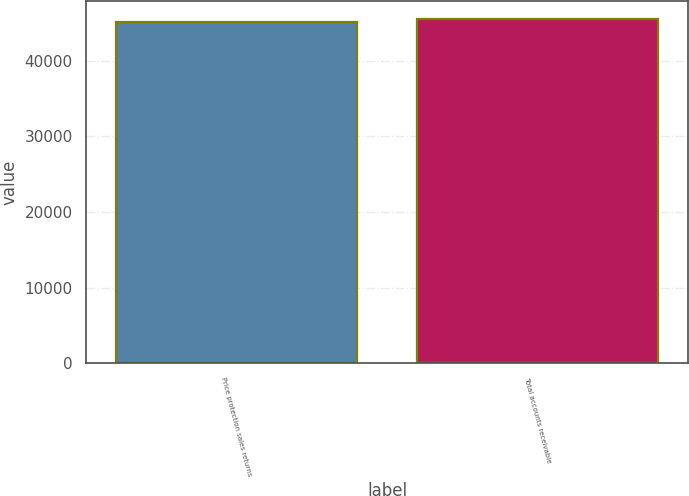Convert chart. <chart><loc_0><loc_0><loc_500><loc_500><bar_chart><fcel>Price protection sales returns<fcel>Total accounts receivable<nl><fcel>45153<fcel>45552<nl></chart> 